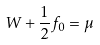Convert formula to latex. <formula><loc_0><loc_0><loc_500><loc_500>W + \frac { 1 } { 2 } f _ { 0 } = \mu</formula> 